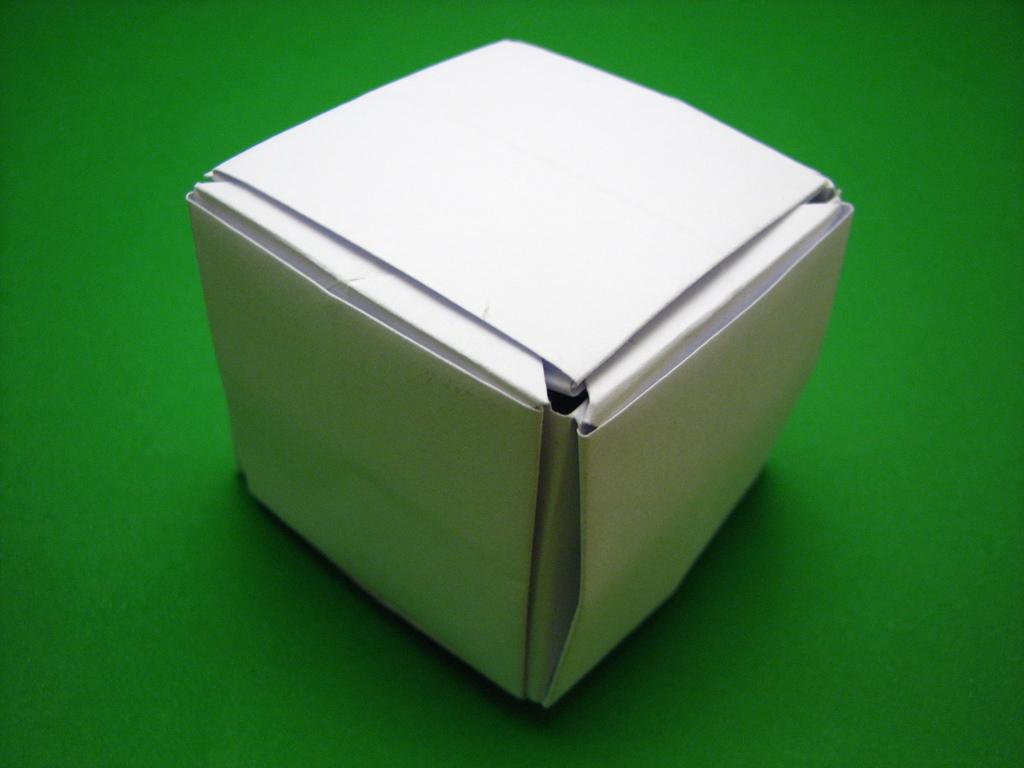What is the color of the box in the image? The box in the image is white. What is the color of the surface on which the box is placed? The surface is green. Can you describe the relationship between the box and the surface? The box is on top of the green surface. How many dimes can be seen stacked on the box in the image? There are no dimes present in the image. What type of beast is hiding behind the box in the image? There is no beast present in the image. 